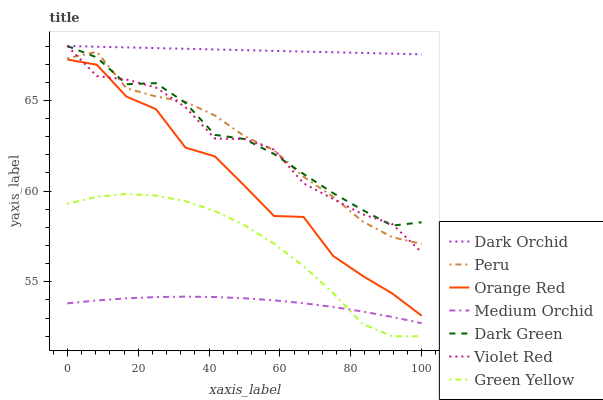Does Dark Orchid have the minimum area under the curve?
Answer yes or no. No. Does Medium Orchid have the maximum area under the curve?
Answer yes or no. No. Is Medium Orchid the smoothest?
Answer yes or no. No. Is Medium Orchid the roughest?
Answer yes or no. No. Does Medium Orchid have the lowest value?
Answer yes or no. No. Does Medium Orchid have the highest value?
Answer yes or no. No. Is Green Yellow less than Dark Orchid?
Answer yes or no. Yes. Is Violet Red greater than Green Yellow?
Answer yes or no. Yes. Does Green Yellow intersect Dark Orchid?
Answer yes or no. No. 